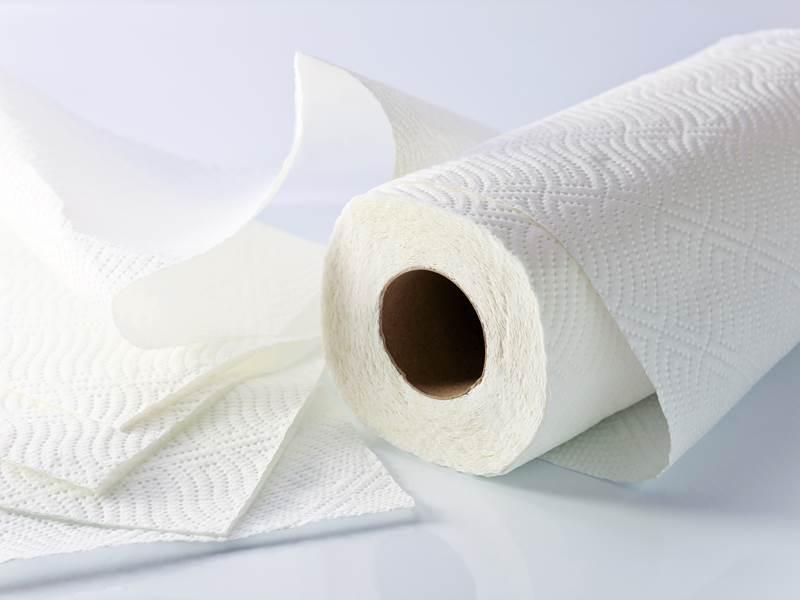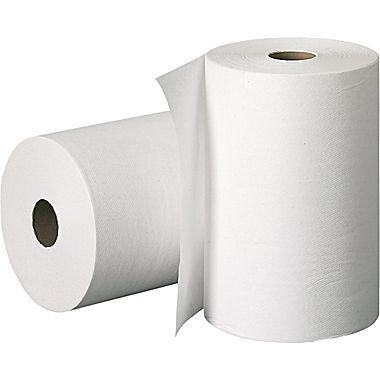The first image is the image on the left, the second image is the image on the right. Considering the images on both sides, is "One image shows exactly one roll standing in front of a roll laying on its side." valid? Answer yes or no. Yes. The first image is the image on the left, the second image is the image on the right. Assess this claim about the two images: "There are three rolls of paper". Correct or not? Answer yes or no. Yes. 